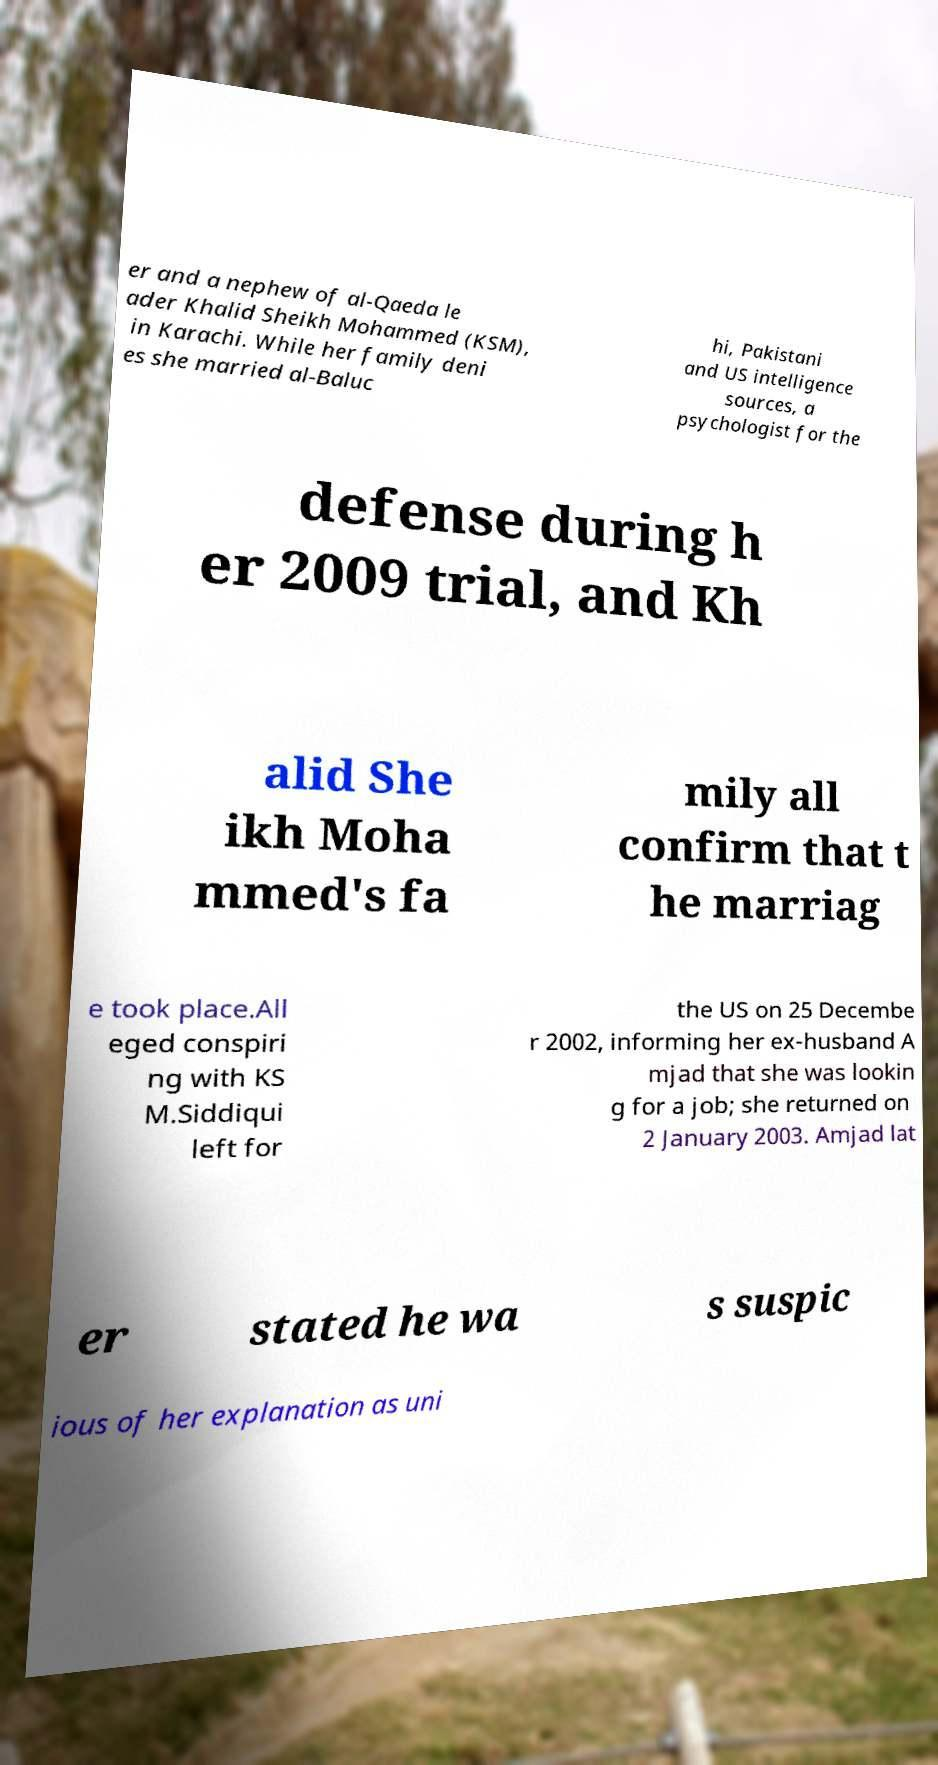Could you extract and type out the text from this image? er and a nephew of al-Qaeda le ader Khalid Sheikh Mohammed (KSM), in Karachi. While her family deni es she married al-Baluc hi, Pakistani and US intelligence sources, a psychologist for the defense during h er 2009 trial, and Kh alid She ikh Moha mmed's fa mily all confirm that t he marriag e took place.All eged conspiri ng with KS M.Siddiqui left for the US on 25 Decembe r 2002, informing her ex-husband A mjad that she was lookin g for a job; she returned on 2 January 2003. Amjad lat er stated he wa s suspic ious of her explanation as uni 